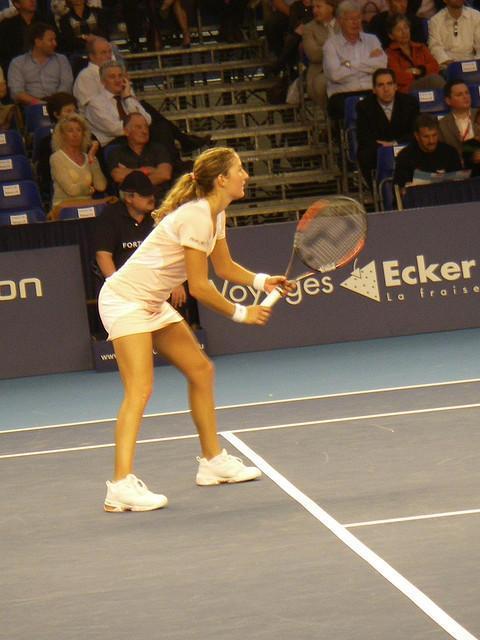How many steps are on the staircase?
Give a very brief answer. 8. How many people can you see?
Give a very brief answer. 13. How many televisions are on the left of the door?
Give a very brief answer. 0. 